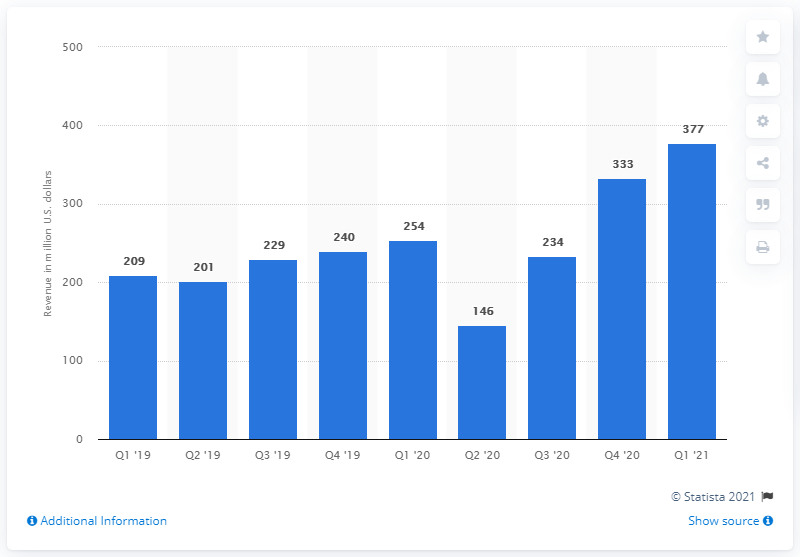Mention a couple of crucial points in this snapshot. In the fourth quarter of 2021, Intel reported revenue of approximately 333... In the first quarter of 2021, the revenue of Intel's Mobileye segment was $377 million. 